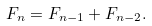Convert formula to latex. <formula><loc_0><loc_0><loc_500><loc_500>F _ { n } = F _ { n - 1 } + F _ { n - 2 } .</formula> 